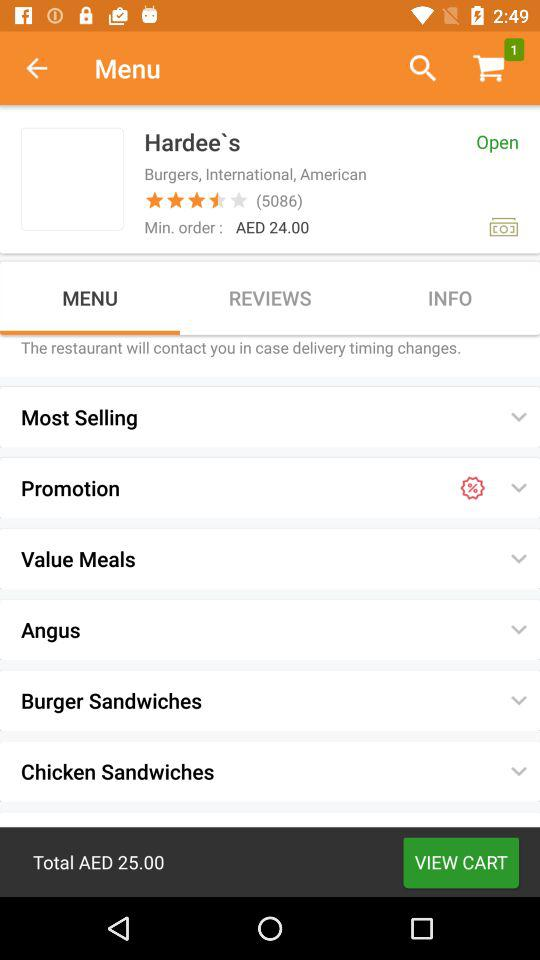What's the total cost of the order? The total cost of the order is AED 25.00. 